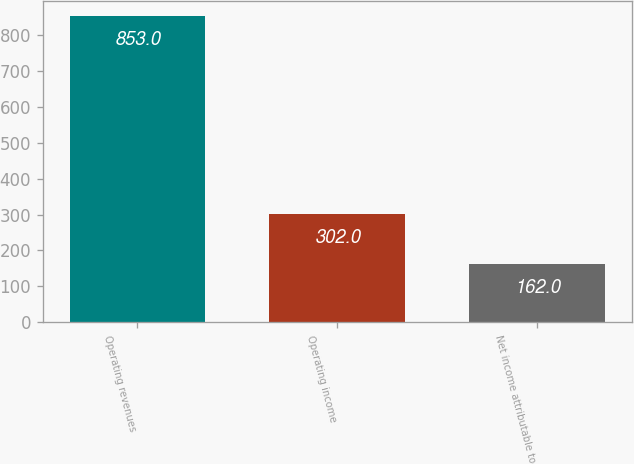<chart> <loc_0><loc_0><loc_500><loc_500><bar_chart><fcel>Operating revenues<fcel>Operating income<fcel>Net income attributable to<nl><fcel>853<fcel>302<fcel>162<nl></chart> 